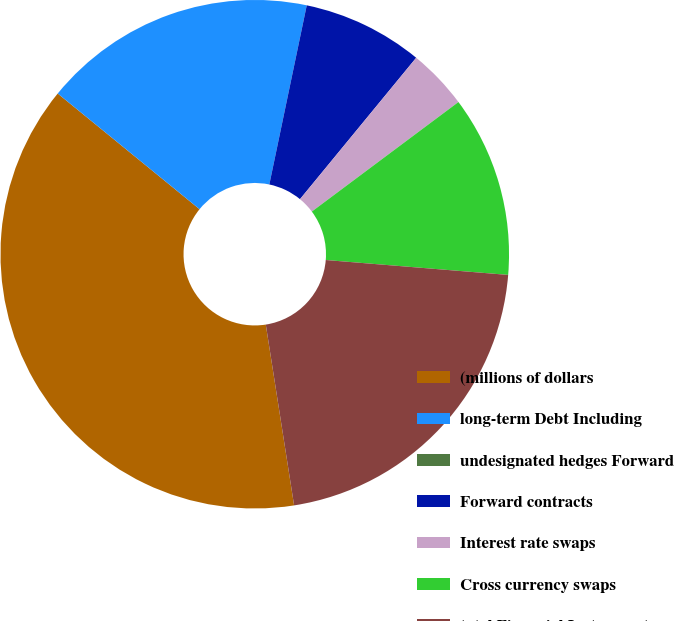<chart> <loc_0><loc_0><loc_500><loc_500><pie_chart><fcel>(millions of dollars<fcel>long-term Debt Including<fcel>undesignated hedges Forward<fcel>Forward contracts<fcel>Interest rate swaps<fcel>Cross currency swaps<fcel>total Financial Instruments<nl><fcel>38.36%<fcel>17.39%<fcel>0.0%<fcel>7.67%<fcel>3.84%<fcel>11.51%<fcel>21.23%<nl></chart> 